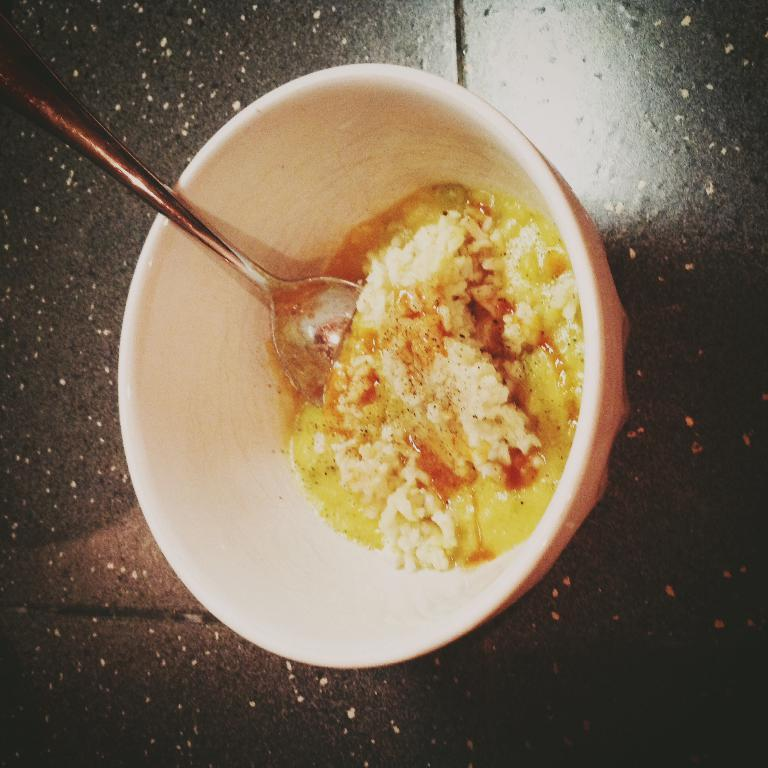What is in the bowl that is visible in the image? There is food in the bowl. What utensil is present in the bowl? There is a spoon in the bowl. Where is the bowl located in the image? The bowl is on a table. What type of stone can be seen in the image? There is no stone present in the image. Are there any slaves depicted in the image? There is no reference to any slaves in the image. 